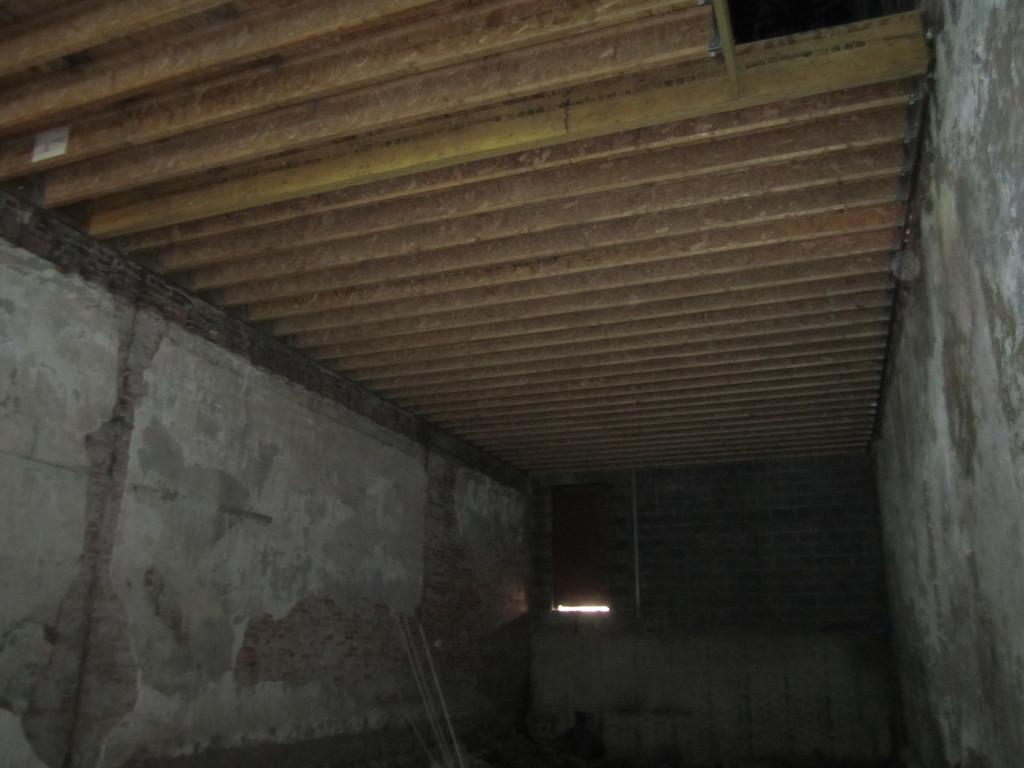What is present on both sides of the image in the foreground? There are walls on both the right and left sides in the foreground of the image. What can be seen in the background of the image? There is a wall in the background of the image. What material is visible at the top of the image? Metal sheets are visible at the top of the image. What type of appliance can be seen on the table in the image? There is no table or appliance present in the image. What type of alley is visible in the image? There is no alley present in the image. 